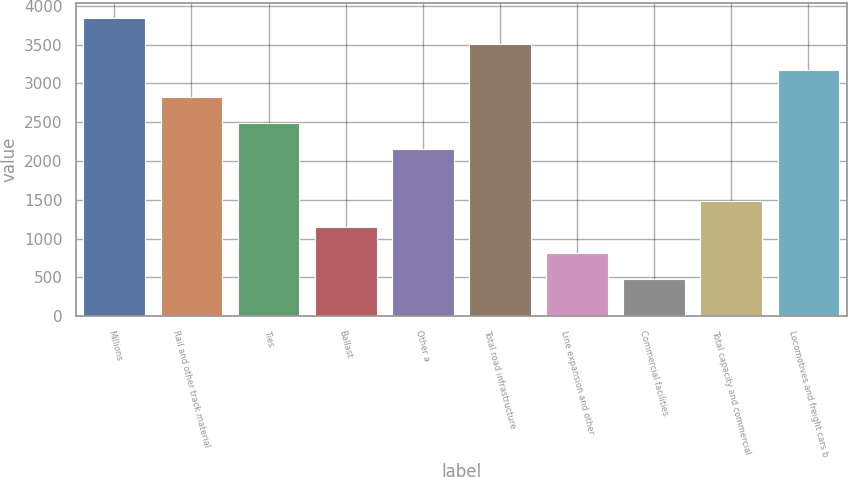Convert chart to OTSL. <chart><loc_0><loc_0><loc_500><loc_500><bar_chart><fcel>Millions<fcel>Rail and other track material<fcel>Ties<fcel>Ballast<fcel>Other a<fcel>Total road infrastructure<fcel>Line expansion and other<fcel>Commercial facilities<fcel>Total capacity and commercial<fcel>Locomotives and freight cars b<nl><fcel>3841.7<fcel>2831.6<fcel>2494.9<fcel>1148.1<fcel>2158.2<fcel>3505<fcel>811.4<fcel>474.7<fcel>1484.8<fcel>3168.3<nl></chart> 